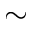Convert formula to latex. <formula><loc_0><loc_0><loc_500><loc_500>\sim</formula> 